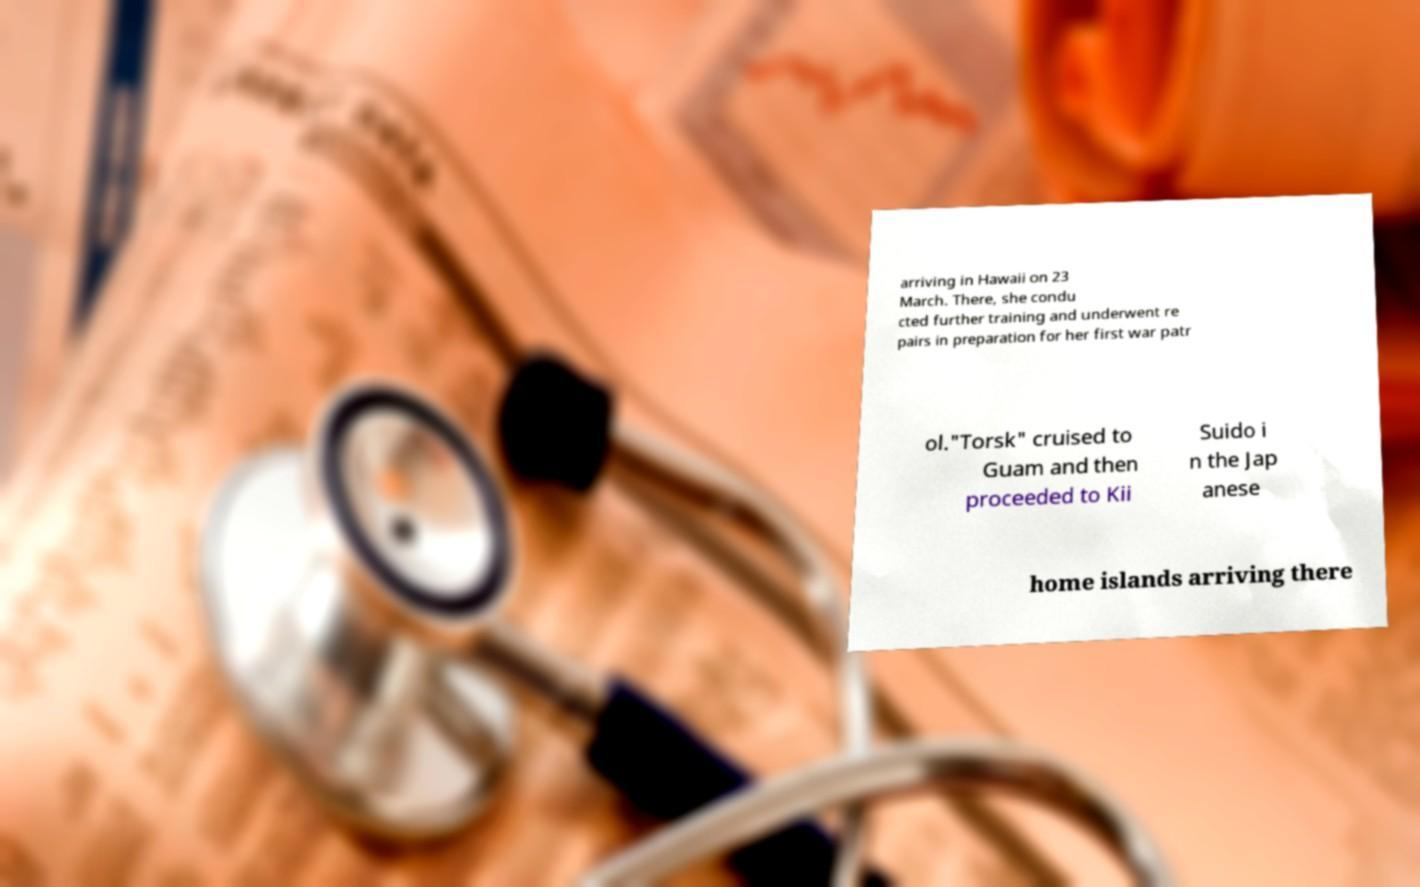Can you accurately transcribe the text from the provided image for me? arriving in Hawaii on 23 March. There, she condu cted further training and underwent re pairs in preparation for her first war patr ol."Torsk" cruised to Guam and then proceeded to Kii Suido i n the Jap anese home islands arriving there 